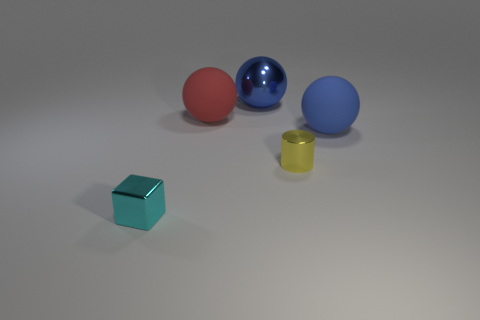Add 1 large metallic balls. How many objects exist? 6 Subtract all large matte balls. How many balls are left? 1 Subtract all cylinders. How many objects are left? 4 Subtract all red blocks. How many blue spheres are left? 2 Subtract 1 cylinders. How many cylinders are left? 0 Subtract all blue rubber spheres. Subtract all small cyan metal blocks. How many objects are left? 3 Add 3 cyan metallic objects. How many cyan metallic objects are left? 4 Add 5 small cyan shiny things. How many small cyan shiny things exist? 6 Subtract all blue spheres. How many spheres are left? 1 Subtract 0 red cylinders. How many objects are left? 5 